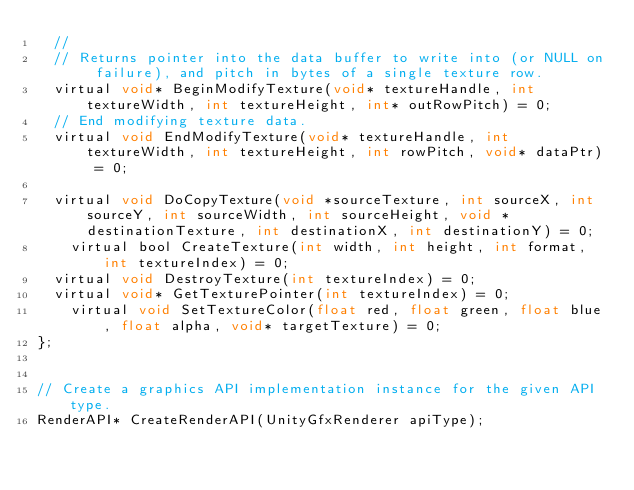Convert code to text. <code><loc_0><loc_0><loc_500><loc_500><_C_>	//
	// Returns pointer into the data buffer to write into (or NULL on failure), and pitch in bytes of a single texture row.
	virtual void* BeginModifyTexture(void* textureHandle, int textureWidth, int textureHeight, int* outRowPitch) = 0;
	// End modifying texture data.
	virtual void EndModifyTexture(void* textureHandle, int textureWidth, int textureHeight, int rowPitch, void* dataPtr) = 0;

	virtual void DoCopyTexture(void *sourceTexture, int sourceX, int sourceY, int sourceWidth, int sourceHeight, void *destinationTexture, int destinationX, int destinationY) = 0;
    virtual bool CreateTexture(int width, int height, int format, int textureIndex) = 0;
	virtual void DestroyTexture(int textureIndex) = 0;
	virtual void* GetTexturePointer(int textureIndex) = 0;
    virtual void SetTextureColor(float red, float green, float blue, float alpha, void* targetTexture) = 0;
};


// Create a graphics API implementation instance for the given API type.
RenderAPI* CreateRenderAPI(UnityGfxRenderer apiType);

</code> 